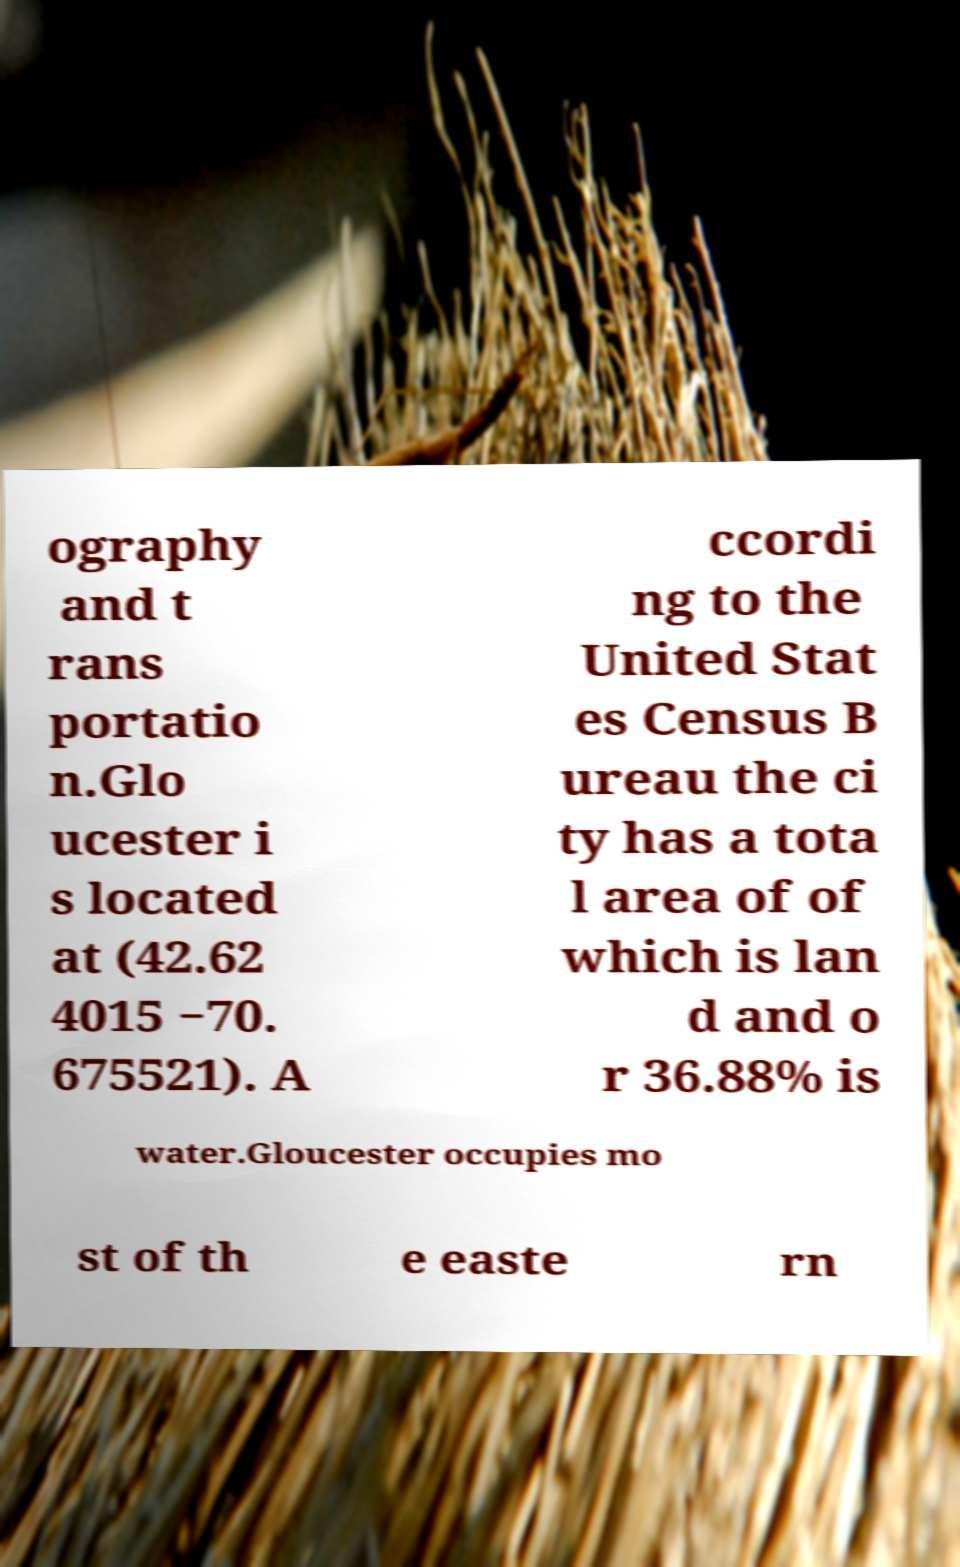There's text embedded in this image that I need extracted. Can you transcribe it verbatim? ography and t rans portatio n.Glo ucester i s located at (42.62 4015 −70. 675521). A ccordi ng to the United Stat es Census B ureau the ci ty has a tota l area of of which is lan d and o r 36.88% is water.Gloucester occupies mo st of th e easte rn 